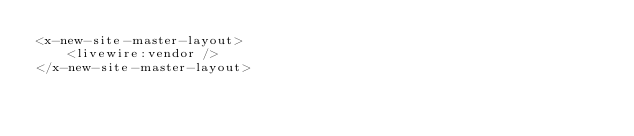<code> <loc_0><loc_0><loc_500><loc_500><_PHP_><x-new-site-master-layout>
    <livewire:vendor />
</x-new-site-master-layout>
</code> 